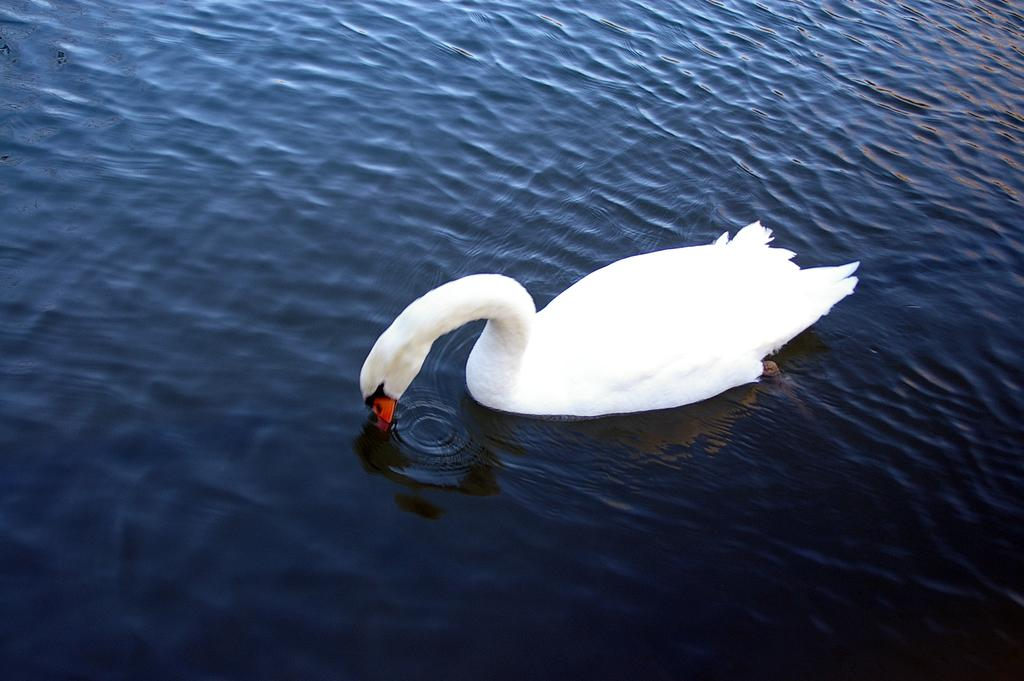Where was the image taken? The image was clicked outside the city. What animal can be seen in the image? There is a white color swan in the image. In what type of environment is the swan located? The swan is in a water body. What is the process used by the creator to capture the image? The facts provided do not mention any specific process or creator involved in capturing the image. 